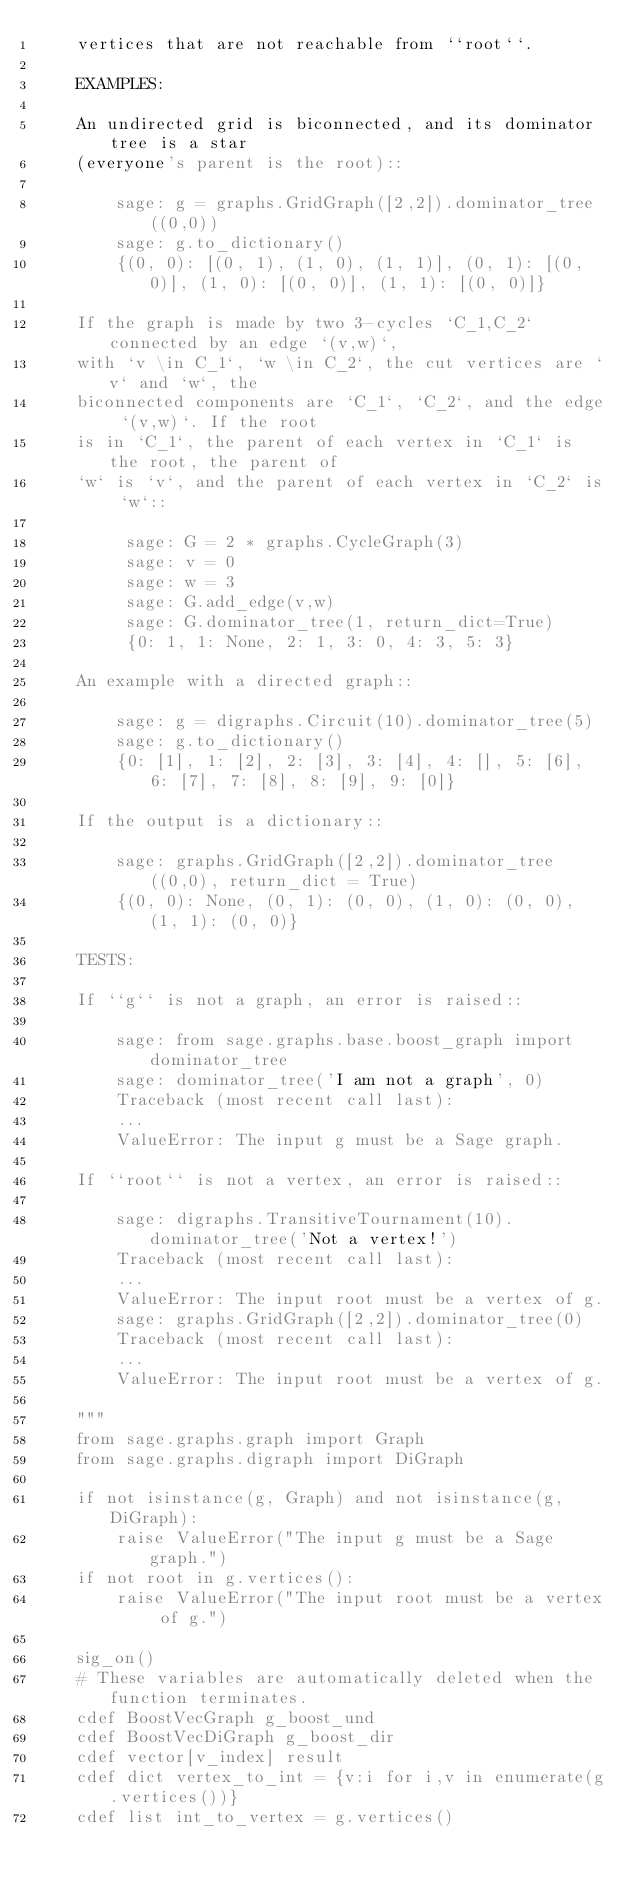<code> <loc_0><loc_0><loc_500><loc_500><_Cython_>    vertices that are not reachable from ``root``.

    EXAMPLES:

    An undirected grid is biconnected, and its dominator tree is a star
    (everyone's parent is the root)::

        sage: g = graphs.GridGraph([2,2]).dominator_tree((0,0))
        sage: g.to_dictionary()
        {(0, 0): [(0, 1), (1, 0), (1, 1)], (0, 1): [(0, 0)], (1, 0): [(0, 0)], (1, 1): [(0, 0)]}

    If the graph is made by two 3-cycles `C_1,C_2` connected by an edge `(v,w)`,
    with `v \in C_1`, `w \in C_2`, the cut vertices are `v` and `w`, the
    biconnected components are `C_1`, `C_2`, and the edge `(v,w)`. If the root
    is in `C_1`, the parent of each vertex in `C_1` is the root, the parent of
    `w` is `v`, and the parent of each vertex in `C_2` is `w`::

         sage: G = 2 * graphs.CycleGraph(3)
         sage: v = 0
         sage: w = 3
         sage: G.add_edge(v,w)
         sage: G.dominator_tree(1, return_dict=True)
         {0: 1, 1: None, 2: 1, 3: 0, 4: 3, 5: 3}

    An example with a directed graph::

        sage: g = digraphs.Circuit(10).dominator_tree(5)
        sage: g.to_dictionary()
        {0: [1], 1: [2], 2: [3], 3: [4], 4: [], 5: [6], 6: [7], 7: [8], 8: [9], 9: [0]}

    If the output is a dictionary::

        sage: graphs.GridGraph([2,2]).dominator_tree((0,0), return_dict = True)
        {(0, 0): None, (0, 1): (0, 0), (1, 0): (0, 0), (1, 1): (0, 0)}

    TESTS:

    If ``g`` is not a graph, an error is raised::

        sage: from sage.graphs.base.boost_graph import dominator_tree
        sage: dominator_tree('I am not a graph', 0)
        Traceback (most recent call last):
        ...
        ValueError: The input g must be a Sage graph.

    If ``root`` is not a vertex, an error is raised::

        sage: digraphs.TransitiveTournament(10).dominator_tree('Not a vertex!')
        Traceback (most recent call last):
        ...
        ValueError: The input root must be a vertex of g.
        sage: graphs.GridGraph([2,2]).dominator_tree(0)
        Traceback (most recent call last):
        ...
        ValueError: The input root must be a vertex of g.

    """
    from sage.graphs.graph import Graph
    from sage.graphs.digraph import DiGraph

    if not isinstance(g, Graph) and not isinstance(g, DiGraph):
        raise ValueError("The input g must be a Sage graph.")
    if not root in g.vertices():
        raise ValueError("The input root must be a vertex of g.")

    sig_on()
    # These variables are automatically deleted when the function terminates.
    cdef BoostVecGraph g_boost_und
    cdef BoostVecDiGraph g_boost_dir
    cdef vector[v_index] result
    cdef dict vertex_to_int = {v:i for i,v in enumerate(g.vertices())}
    cdef list int_to_vertex = g.vertices()
</code> 